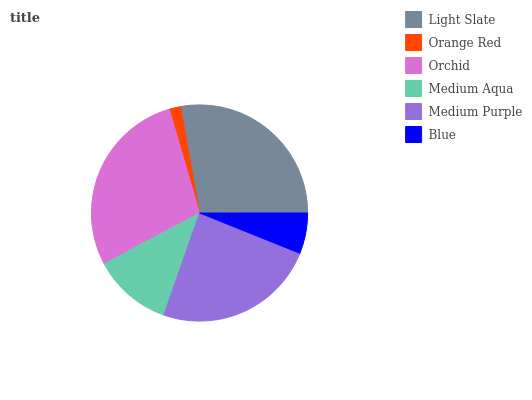Is Orange Red the minimum?
Answer yes or no. Yes. Is Orchid the maximum?
Answer yes or no. Yes. Is Orchid the minimum?
Answer yes or no. No. Is Orange Red the maximum?
Answer yes or no. No. Is Orchid greater than Orange Red?
Answer yes or no. Yes. Is Orange Red less than Orchid?
Answer yes or no. Yes. Is Orange Red greater than Orchid?
Answer yes or no. No. Is Orchid less than Orange Red?
Answer yes or no. No. Is Medium Purple the high median?
Answer yes or no. Yes. Is Medium Aqua the low median?
Answer yes or no. Yes. Is Orchid the high median?
Answer yes or no. No. Is Orchid the low median?
Answer yes or no. No. 